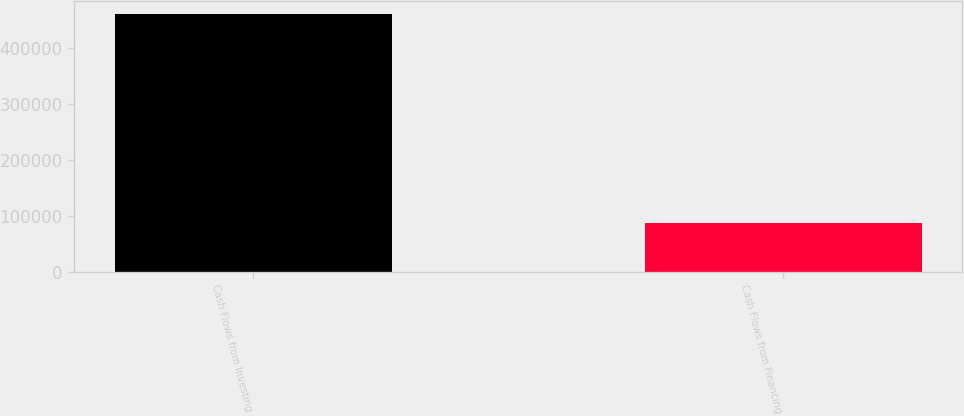<chart> <loc_0><loc_0><loc_500><loc_500><bar_chart><fcel>Cash Flows from Investing<fcel>Cash Flows from Financing<nl><fcel>459594<fcel>87368<nl></chart> 